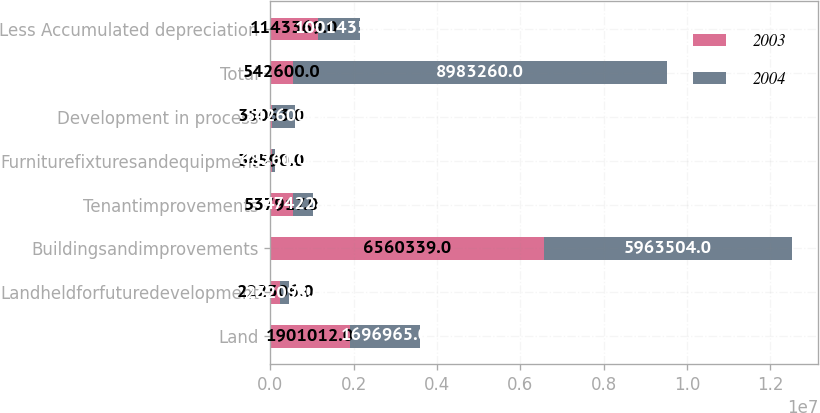Convert chart to OTSL. <chart><loc_0><loc_0><loc_500><loc_500><stacked_bar_chart><ecel><fcel>Land<fcel>Landheldforfuturedevelopment<fcel>Buildingsandimprovements<fcel>Tenantimprovements<fcel>Furniturefixturesandequipment<fcel>Development in process<fcel>Total<fcel>Less Accumulated depreciation<nl><fcel>2003<fcel>1.90101e+06<fcel>222306<fcel>6.56034e+06<fcel>537917<fcel>34590<fcel>35063<fcel>542600<fcel>1.14337e+06<nl><fcel>2004<fcel>1.69696e+06<fcel>232098<fcel>5.9635e+06<fcel>474228<fcel>68261<fcel>542600<fcel>8.98326e+06<fcel>1.00144e+06<nl></chart> 